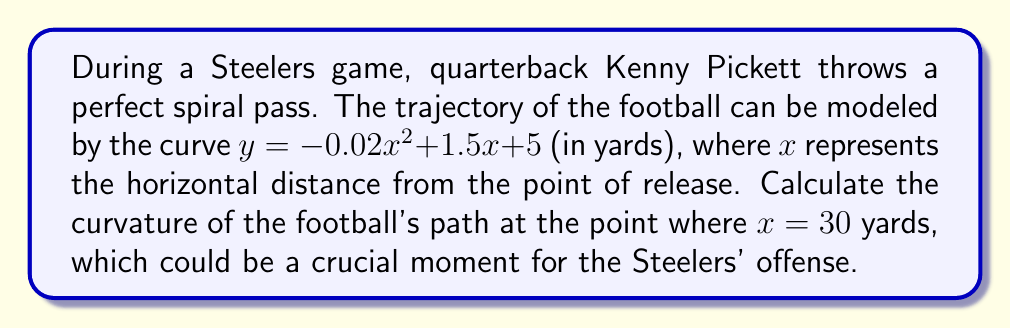What is the answer to this math problem? To determine the curvature of the football's trajectory, we'll follow these steps:

1) The general formula for curvature $K$ of a curve $y = f(x)$ is:

   $$K = \frac{|f''(x)|}{(1 + (f'(x))^2)^{3/2}}$$

2) First, let's find $f'(x)$ and $f''(x)$:
   
   $f'(x) = -0.04x + 1.5$
   $f''(x) = -0.04$

3) At $x = 30$:
   
   $f'(30) = -0.04(30) + 1.5 = 0.3$

4) Now, let's substitute these values into the curvature formula:

   $$K = \frac{|-0.04|}{(1 + (0.3)^2)^{3/2}}$$

5) Simplify:
   
   $$K = \frac{0.04}{(1 + 0.09)^{3/2}} = \frac{0.04}{(1.09)^{3/2}}$$

6) Calculate the final value:
   
   $$K \approx 0.0374$$

This curvature value represents how quickly the trajectory is bending at the 30-yard point. A lower value indicates a flatter trajectory, which could be beneficial for long passes in the Steelers' offensive strategy.
Answer: $K \approx 0.0374$ yd$^{-1}$ 